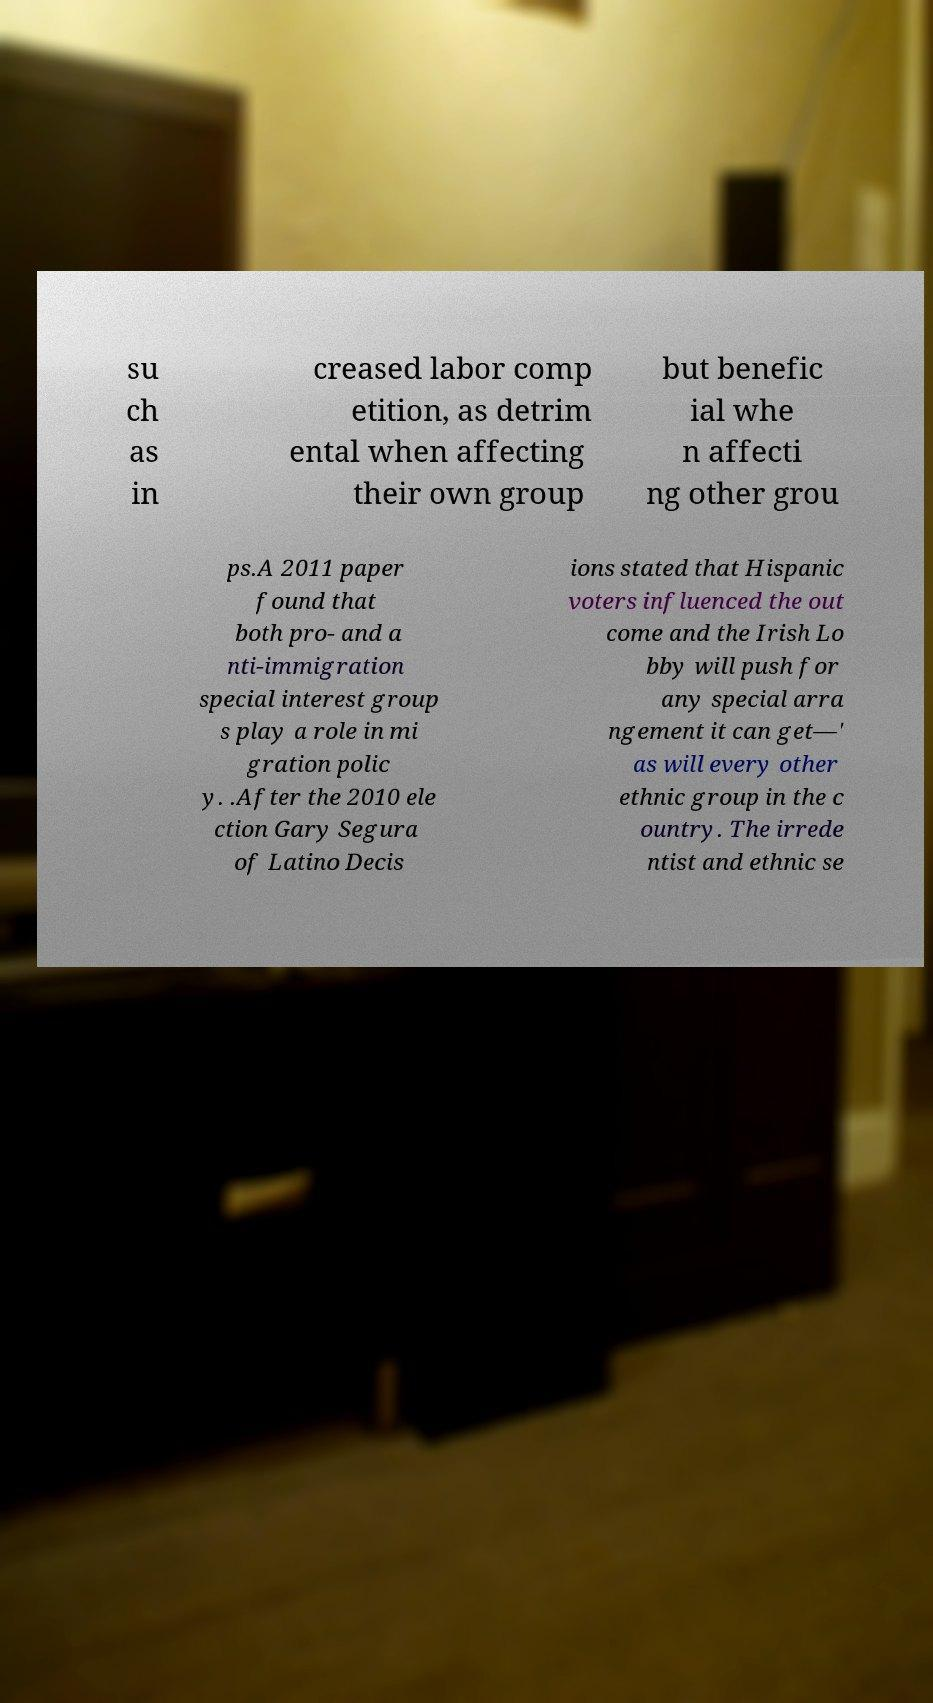Can you read and provide the text displayed in the image?This photo seems to have some interesting text. Can you extract and type it out for me? su ch as in creased labor comp etition, as detrim ental when affecting their own group but benefic ial whe n affecti ng other grou ps.A 2011 paper found that both pro- and a nti-immigration special interest group s play a role in mi gration polic y. .After the 2010 ele ction Gary Segura of Latino Decis ions stated that Hispanic voters influenced the out come and the Irish Lo bby will push for any special arra ngement it can get—' as will every other ethnic group in the c ountry. The irrede ntist and ethnic se 